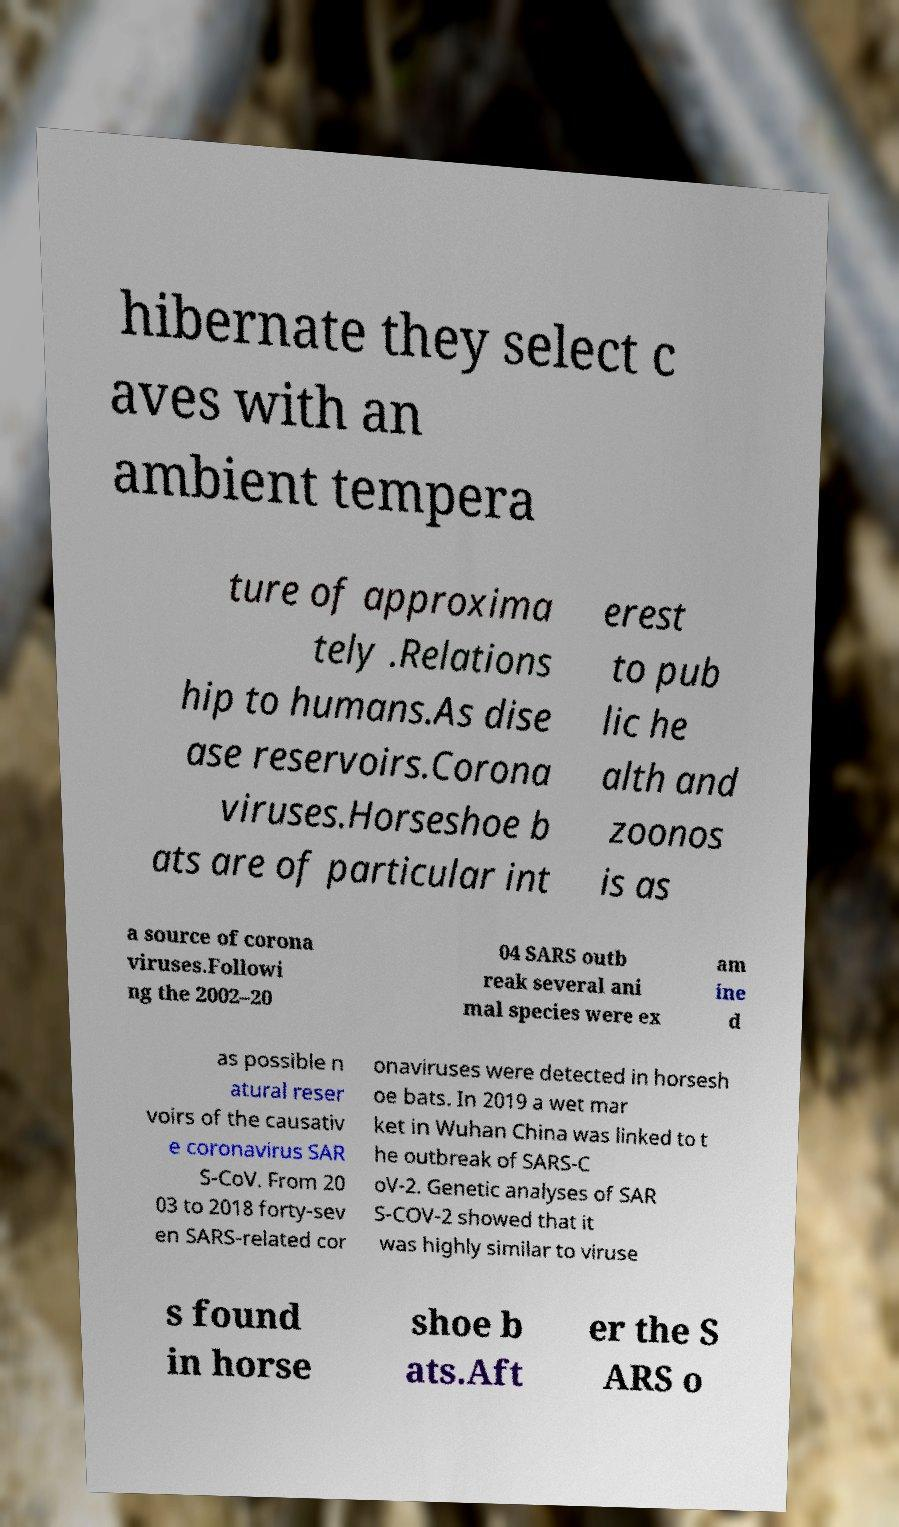Could you extract and type out the text from this image? hibernate they select c aves with an ambient tempera ture of approxima tely .Relations hip to humans.As dise ase reservoirs.Corona viruses.Horseshoe b ats are of particular int erest to pub lic he alth and zoonos is as a source of corona viruses.Followi ng the 2002–20 04 SARS outb reak several ani mal species were ex am ine d as possible n atural reser voirs of the causativ e coronavirus SAR S-CoV. From 20 03 to 2018 forty-sev en SARS-related cor onaviruses were detected in horsesh oe bats. In 2019 a wet mar ket in Wuhan China was linked to t he outbreak of SARS-C oV-2. Genetic analyses of SAR S-COV-2 showed that it was highly similar to viruse s found in horse shoe b ats.Aft er the S ARS o 